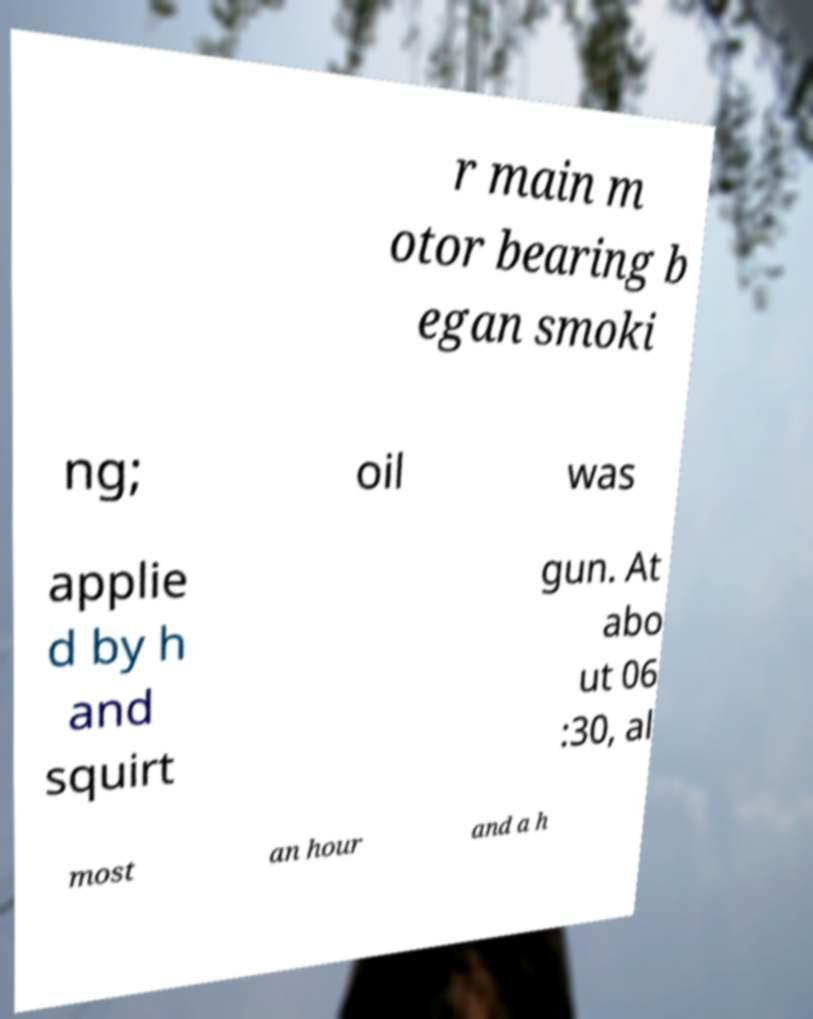Please read and relay the text visible in this image. What does it say? r main m otor bearing b egan smoki ng; oil was applie d by h and squirt gun. At abo ut 06 :30, al most an hour and a h 